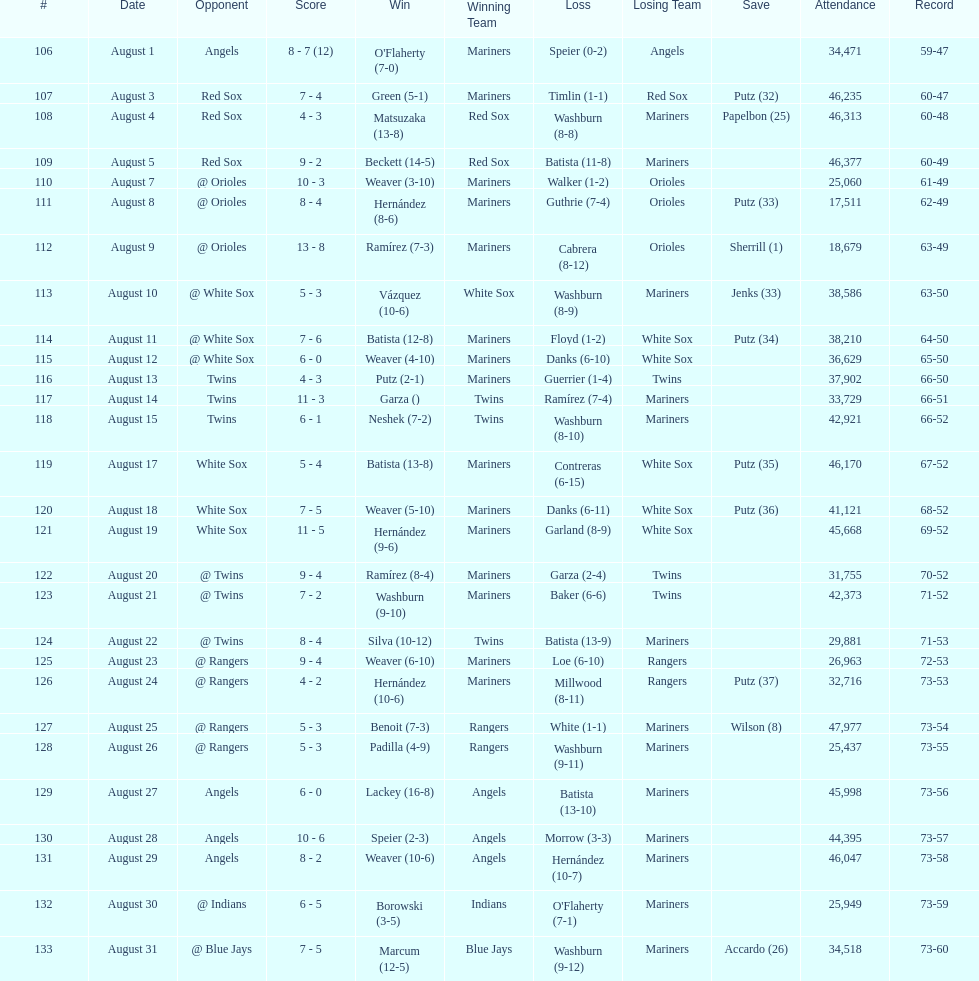How many losses during stretch? 7. 